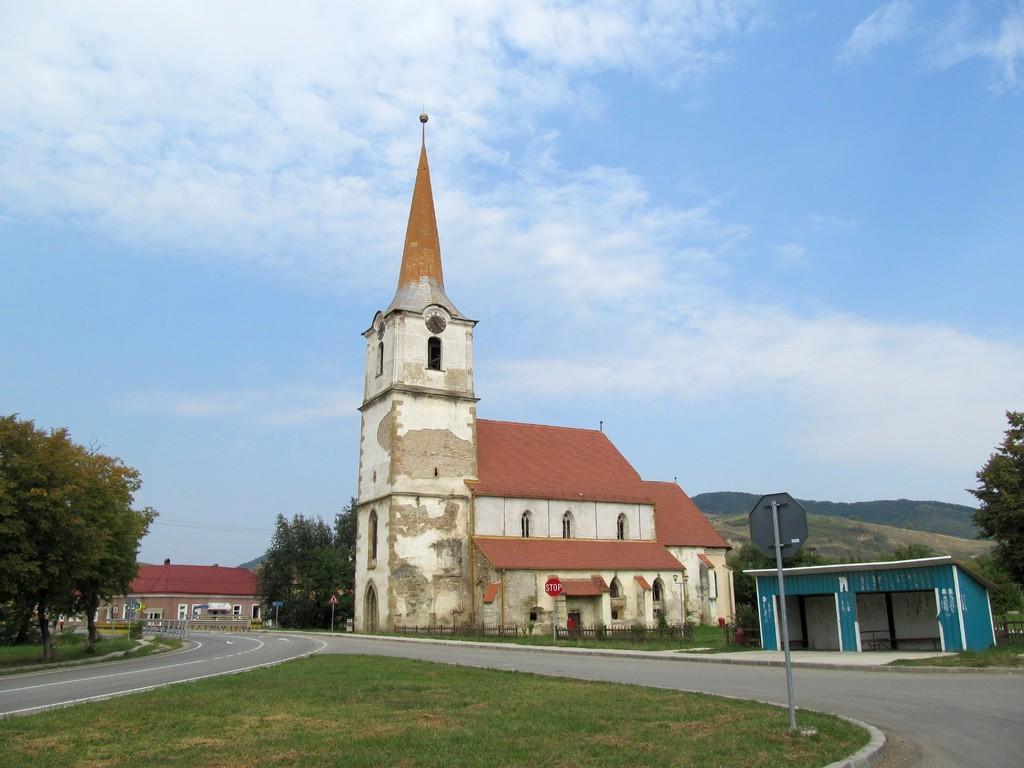Can you describe this image briefly? In this image I can see the buildings and the houses and also the shed. In-front of the building I can see the road and to the side I can see there are boards. In the back there are trees, mountains, clouds and the blue sky. 